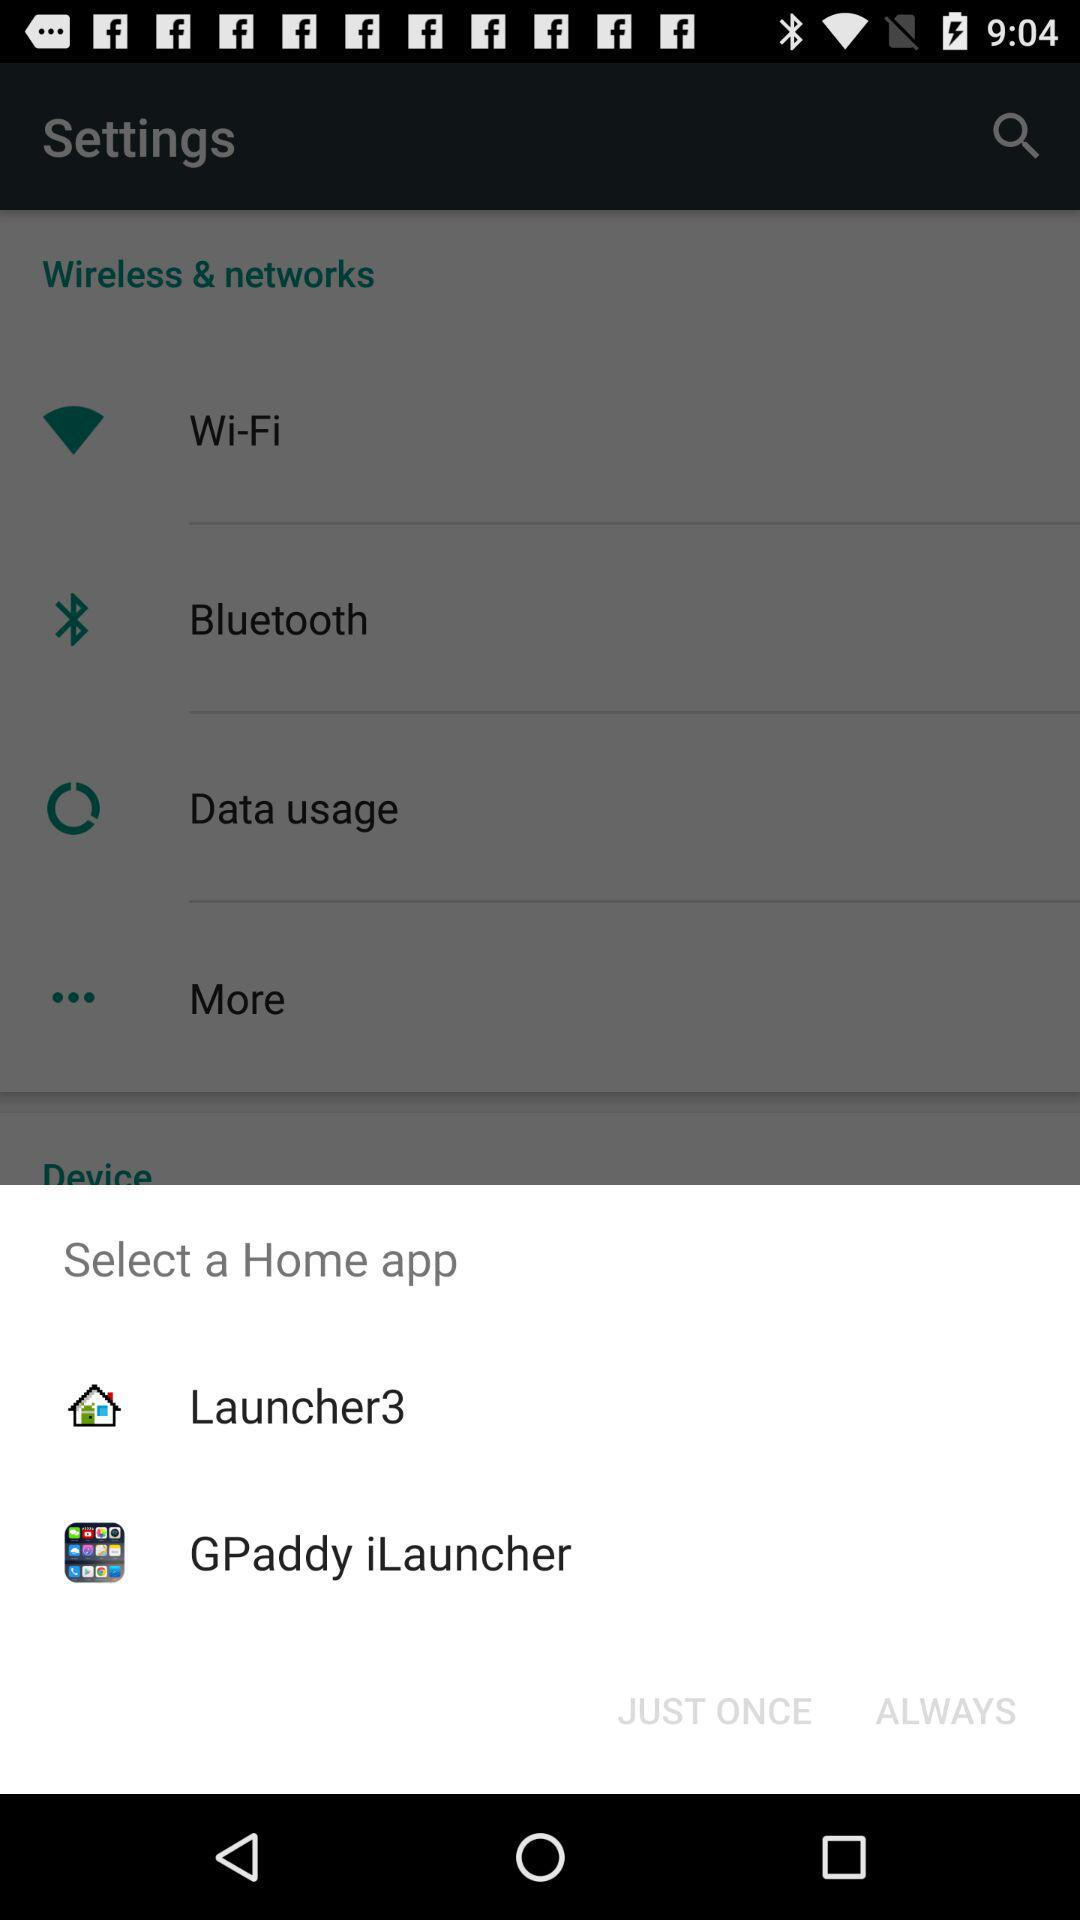What are the given home applications? The given home applications are "Launcher3" and "GPaddy iLaucher". 